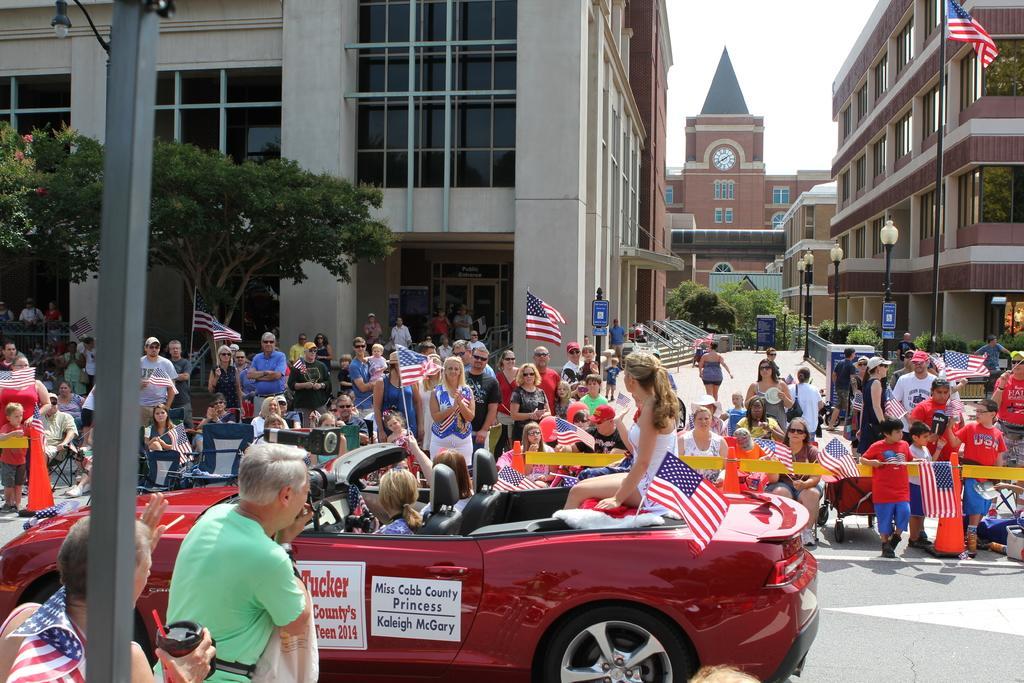Please provide a concise description of this image. In this image, we can see a crowd in front of buildings. There is a pole on the left and on the right side of the image. There are three persons sitting in a car which is at the bottom of the image. There are some persons holding flags with their hands. There is a tree in front of the building. 